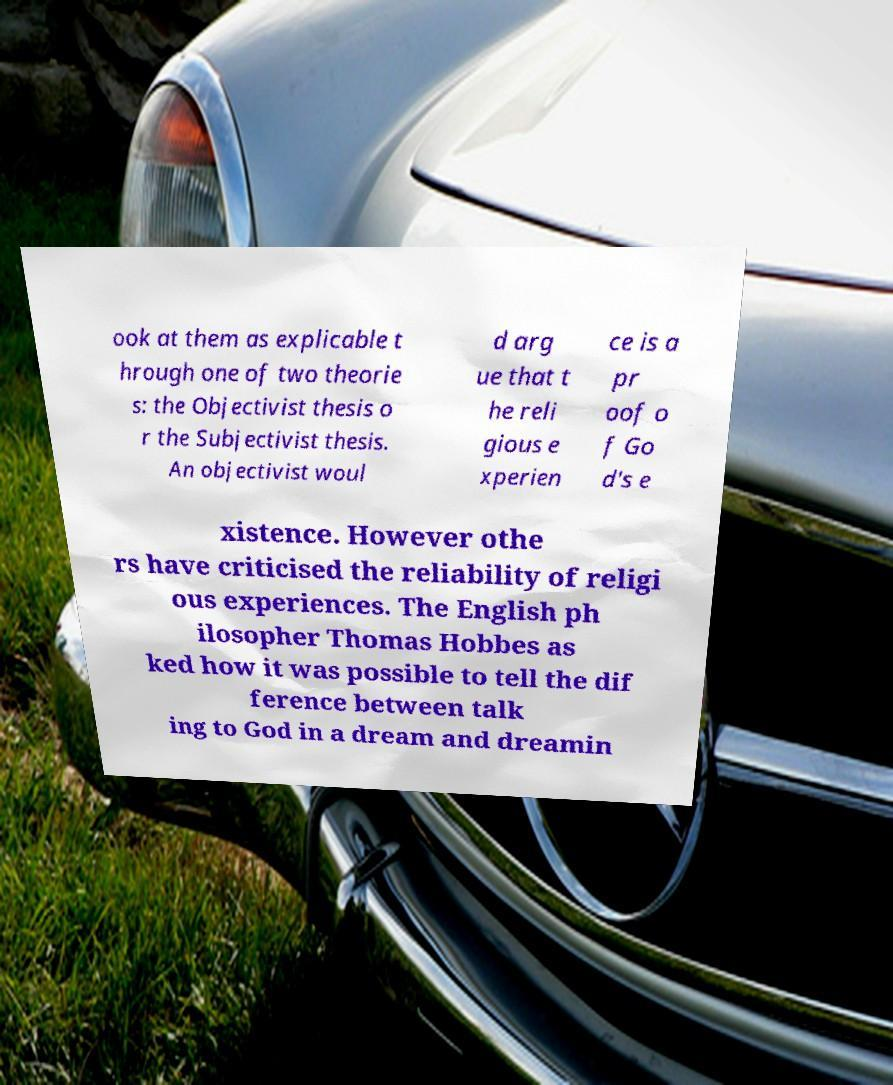Can you accurately transcribe the text from the provided image for me? ook at them as explicable t hrough one of two theorie s: the Objectivist thesis o r the Subjectivist thesis. An objectivist woul d arg ue that t he reli gious e xperien ce is a pr oof o f Go d's e xistence. However othe rs have criticised the reliability of religi ous experiences. The English ph ilosopher Thomas Hobbes as ked how it was possible to tell the dif ference between talk ing to God in a dream and dreamin 